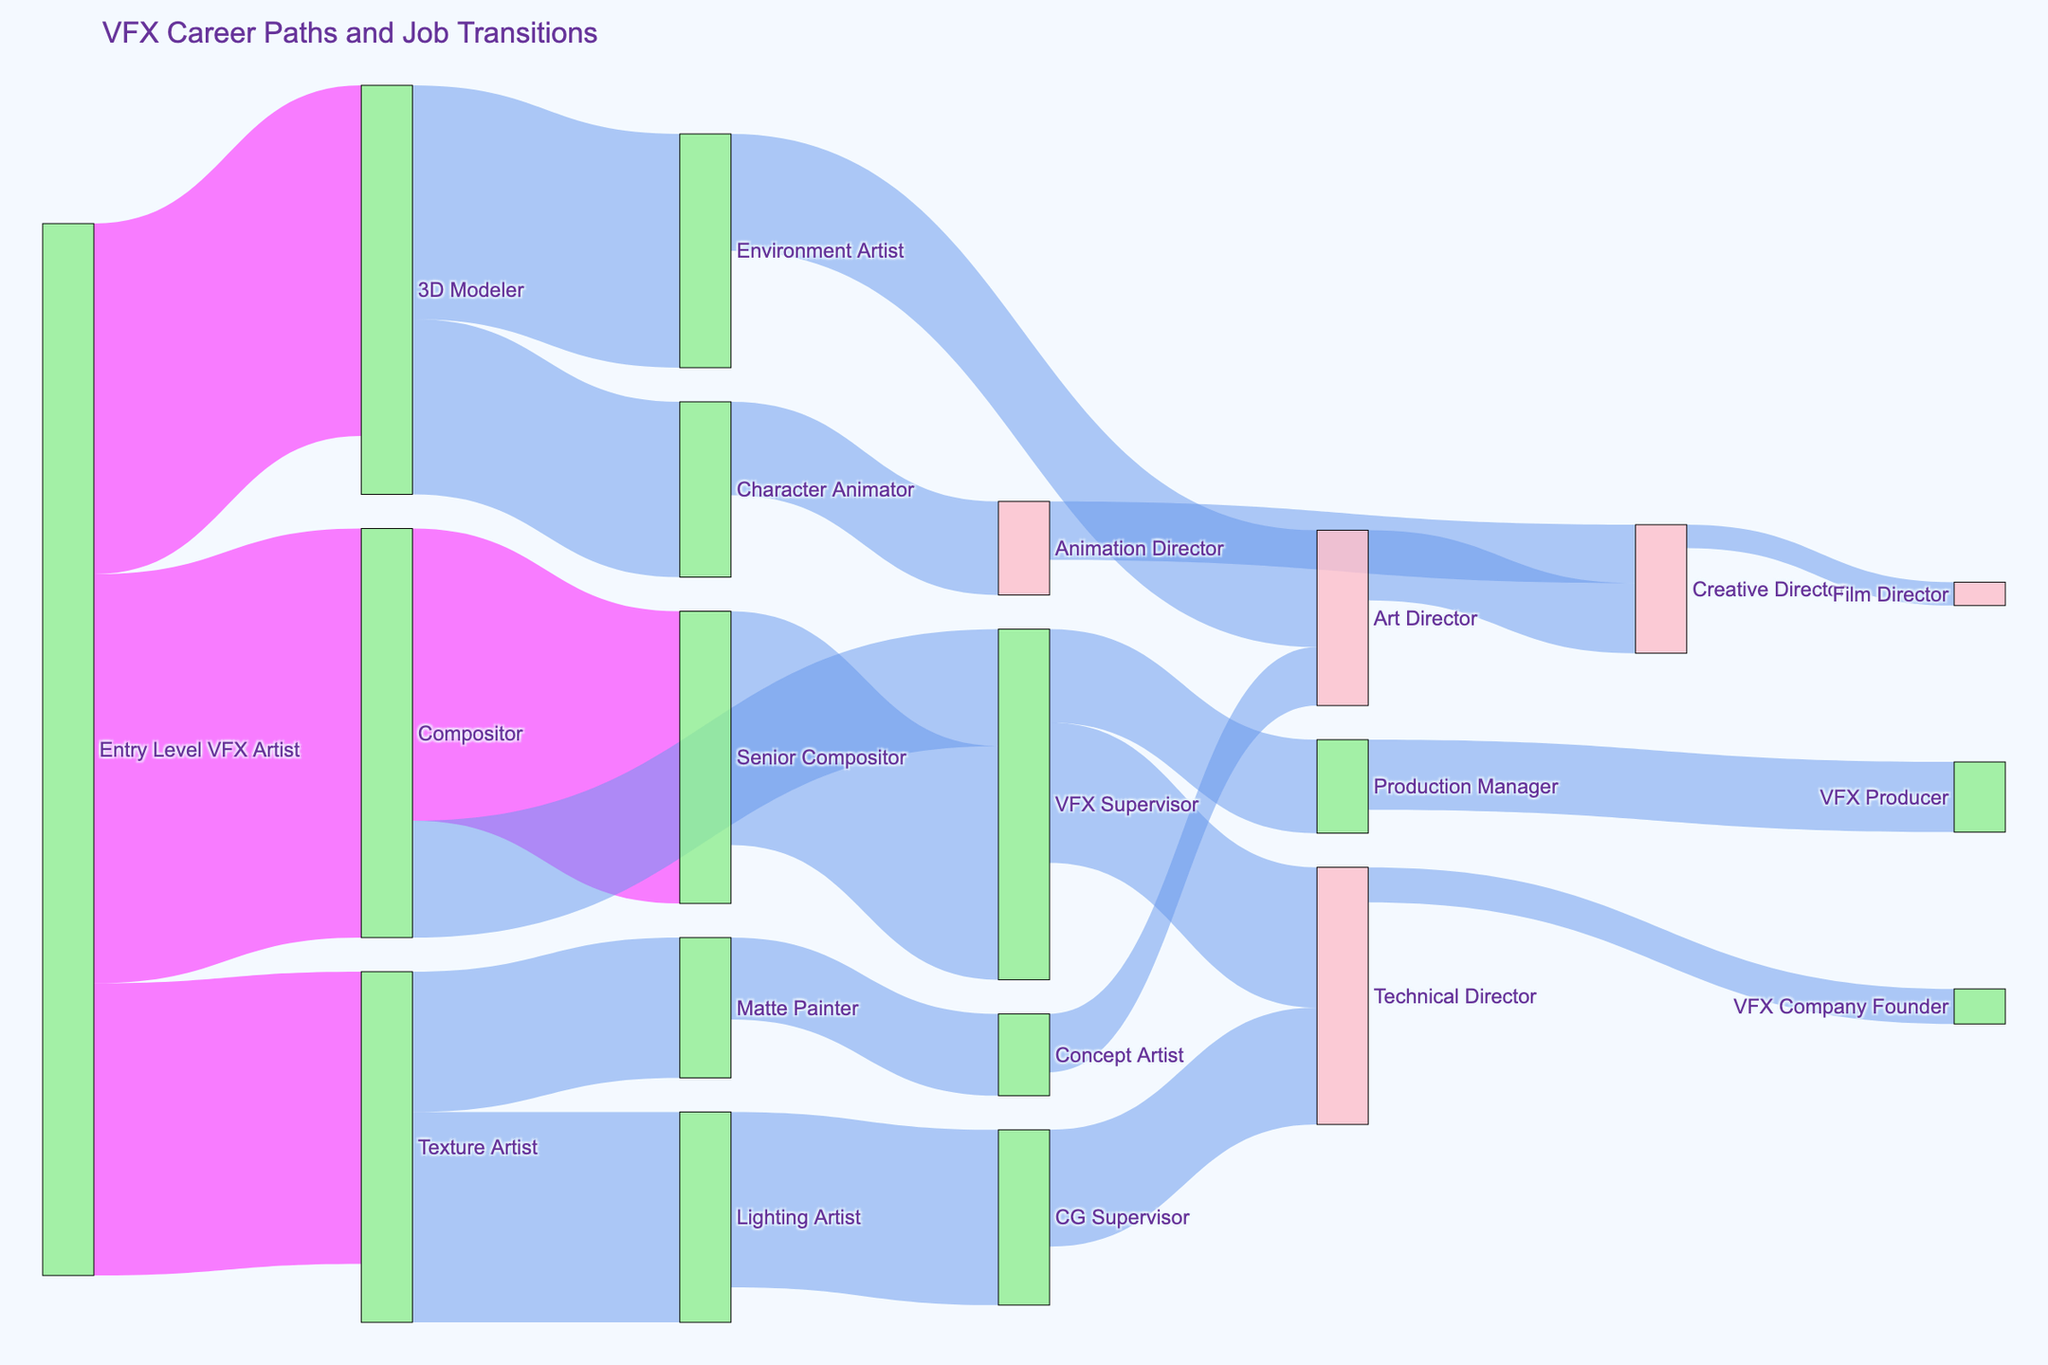What's the primary job transition for an Entry Level VFX Artist? Analyze the source nodes for Entry Level VFX Artist and see the target nodes. The primary job transitions are to become a 3D Modeler, Texture Artist, or Compositor. The highest value among these is toward Compositor with a value of 35.
Answer: Compositor Which job role has the highest transition to VFX Supervisor? Observe the links leading to VFX Supervisor. The job roles that lead to VFX Supervisor are Compositor and Senior Compositor. The highest value link is from Senior Compositor with a value of 20.
Answer: Senior Compositor How many job transitions are there from Texture Artist to other roles? Identify the transitions from Texture Artist. There are two transitions, one to Lighting Artist (18) and another to Matte Painter (12). Adding these values gives 18 + 12 = 30.
Answer: 30 What's the sum of job transitions that lead to Director roles (Creative Director or Film Director)? Identify all links leading to Creative Director and Film Director. The roles leading to Creative Director are Art Director (6) and Animation Director (5), summing these gives 6 + 5 = 11. The role leading to Film Director is Creative Director (2). Therefore, 11 + 2 = 13.
Answer: 13 Which transition has more job transitions: from 3D Modeler to Character Animator or from Character Animator to Animation Director? Compare the values of the transitions from 3D Modeler to Character Animator (15) and Character Animator to Animation Director (8). The transition from 3D Modeler to Character Animator has a higher value.
Answer: 3D Modeler to Character Animator What is the total number of job transitions leading up to Technical Director? Identify the paths leading to Technical Director. The paths are VFX Supervisor (12) and CG Supervisor (10). Summing these gives 12 + 10 = 22.
Answer: 22 Which role has fewer job transitions to becoming a VFX Company Founder: Production Manager or Technical Director? Identify and compare the values leading to VFX Company Founder. Only the transition from Technical Director to VFX Company Founder is shown with a value of 3. Production Manager doesn't transition to VFX Company Founder directly. Therefore, Technical Director is the only one shown leading to that role.
Answer: Technical Director What's the combined value of transitions from Compositor to Senior Compositor and from Senior Compositor to VFX Supervisor? Sum the transitions from Compositor to Senior Compositor (25) and from Senior Compositor to VFX Supervisor (20). The combined value is 25 + 20 = 45.
Answer: 45 When looking at all transitions leading to Executive roles (Technical Director, Production Manager, Creative Director, Film Director, or VFX Company Founder), what’s their combined value? Identify all transitions leading to these roles and sum their values. To Technical Director: VFX Supervisor (12) and CG Supervisor (10), to Production Manager: VFX Supervisor (8), to Creative Director: Animation Director (5) and Art Director (6), to Film Director: Creative Director (2), to VFX Company Founder: Technical Director (3). Summing these gives 12 + 10 + 8 + 5 + 6 + 2 + 3 = 46.
Answer: 46 